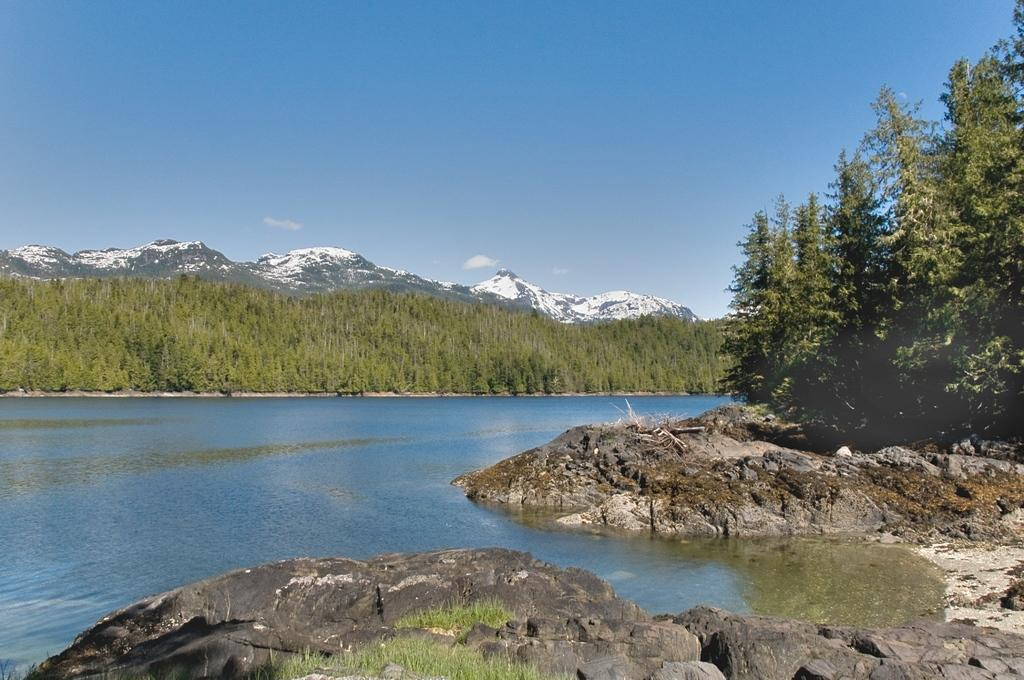What can be seen in the foreground of the image? In the foreground of the image, there are rocks, water, and a tree. What is visible in the background of the image? In the background of the image, there are trees, mountains, and the sky. How many trees are visible in the foreground of the image? There is one tree visible in the foreground of the image. Can you see a guitar being played by a chicken in the image? No, there is no guitar or chicken present in the image. 